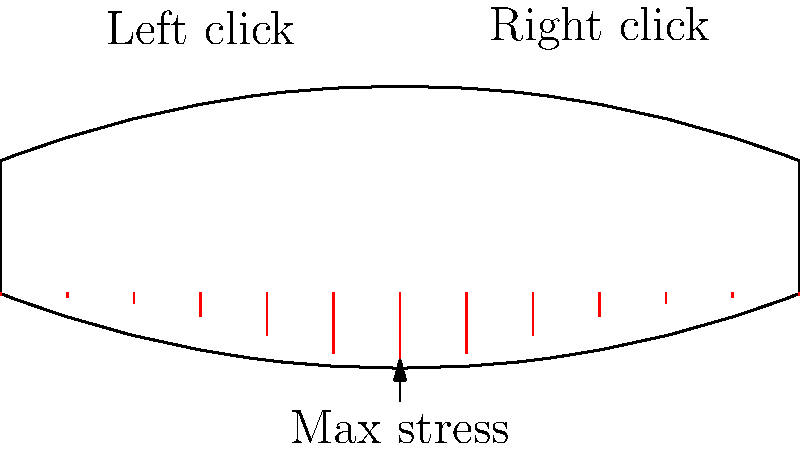In the context of esports gaming, where rapid and repetitive clicking is common, analyze the stress distribution on a gaming mouse during intense usage. Based on the diagram, which area of the mouse is likely to experience the highest stress concentration, and how might this impact the longevity of the device for professional gamers who rely on their equipment for extended periods? To analyze the stress distribution on a gaming mouse during intense clicking, we need to consider several factors:

1. Clicking mechanism: The left and right click buttons are the primary areas of interaction.

2. Stress concentration: The center area between the clicks experiences the highest stress, as shown by the longer red lines in the diagram.

3. Reasons for central stress:
   a) Force distribution: Clicking forces from both buttons converge in the center.
   b) Structural design: The mouse's shape may contribute to stress focusing in this area.

4. Impact on longevity:
   a) Material fatigue: Repeated stress can lead to material weakening over time.
   b) Potential failure points: The high-stress area is more likely to develop cracks or deform.

5. Relevance to esports athletes:
   a) Performance: Consistent equipment behavior is crucial for competitive gaming.
   b) Reliability: Long-term durability is essential for athletes who train and compete extensively.

6. Design considerations:
   a) Material selection: Using materials with high fatigue resistance in high-stress areas.
   b) Structural reinforcement: Implementing designs that distribute stress more evenly.

7. Maintenance implications:
   a) Regular inspections: Checking for signs of wear in the high-stress region.
   b) Replacement schedule: Considering proactive replacement to maintain optimal performance.

Understanding this stress distribution is crucial for both manufacturers designing durable gaming mice and for esports athletes managing their equipment effectively.
Answer: Central area between left and right clicks; reduces longevity through material fatigue and potential failure. 